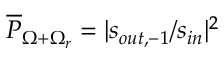<formula> <loc_0><loc_0><loc_500><loc_500>\overline { P } _ { \Omega + \Omega _ { r } } = | s _ { o u t , - 1 } / s _ { i n } | ^ { 2 }</formula> 